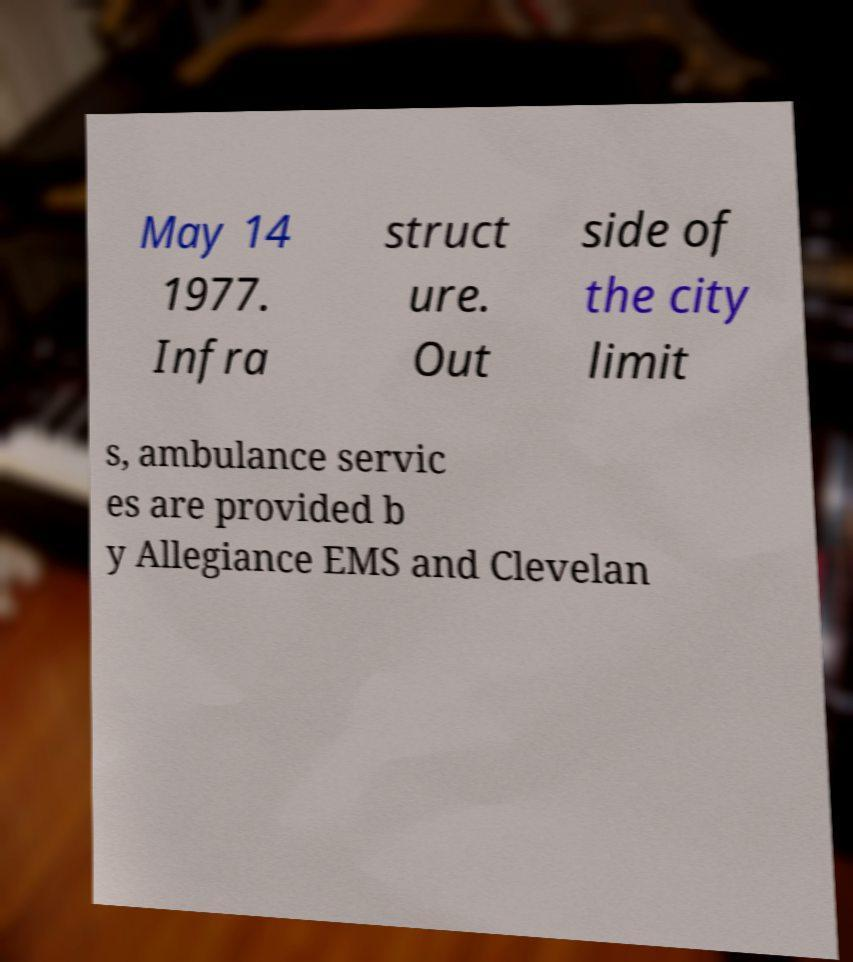Could you assist in decoding the text presented in this image and type it out clearly? May 14 1977. Infra struct ure. Out side of the city limit s, ambulance servic es are provided b y Allegiance EMS and Clevelan 